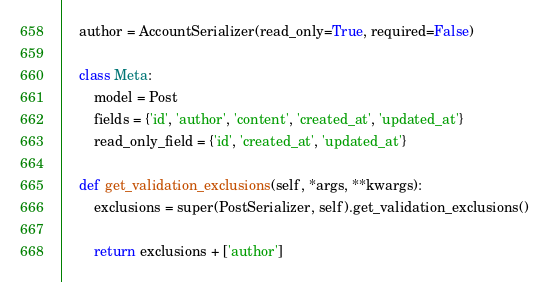<code> <loc_0><loc_0><loc_500><loc_500><_Python_>    author = AccountSerializer(read_only=True, required=False)

    class Meta:
        model = Post
        fields = {'id', 'author', 'content', 'created_at', 'updated_at'}
        read_only_field = {'id', 'created_at', 'updated_at'}

    def get_validation_exclusions(self, *args, **kwargs):
        exclusions = super(PostSerializer, self).get_validation_exclusions()

        return exclusions + ['author']
</code> 